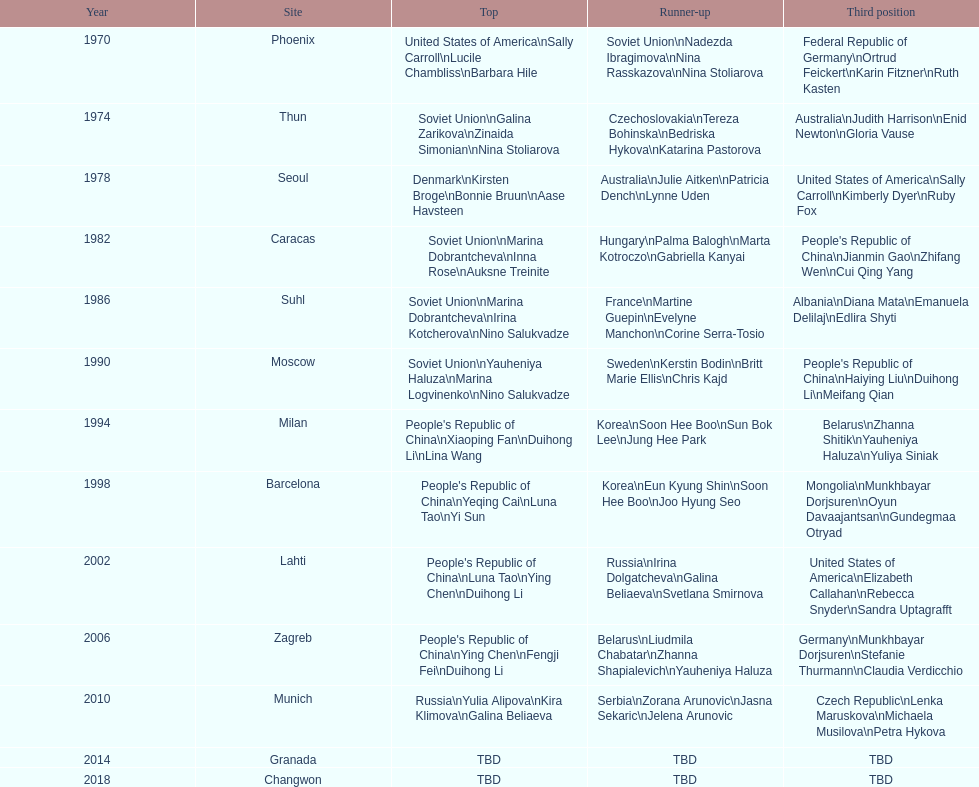Which country is listed the most under the silver column? Korea. 